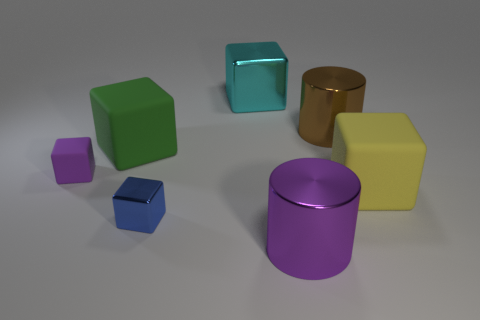Subtract all big green blocks. How many blocks are left? 4 Subtract all blue cubes. How many cubes are left? 4 Add 1 large purple cubes. How many objects exist? 8 Subtract all brown blocks. Subtract all gray cylinders. How many blocks are left? 5 Add 2 large purple metal objects. How many large purple metal objects exist? 3 Subtract 0 cyan cylinders. How many objects are left? 7 Subtract all blocks. How many objects are left? 2 Subtract all big green rubber spheres. Subtract all big purple metal objects. How many objects are left? 6 Add 7 large cyan things. How many large cyan things are left? 8 